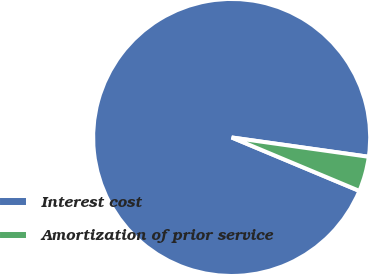<chart> <loc_0><loc_0><loc_500><loc_500><pie_chart><fcel>Interest cost<fcel>Amortization of prior service<nl><fcel>95.92%<fcel>4.08%<nl></chart> 